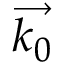Convert formula to latex. <formula><loc_0><loc_0><loc_500><loc_500>\overrightarrow { k _ { 0 } }</formula> 